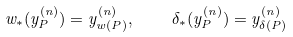<formula> <loc_0><loc_0><loc_500><loc_500>w _ { * } ( y _ { P } ^ { ( n ) } ) = y _ { w ( P ) } ^ { ( n ) } , \quad \delta _ { * } ( y _ { P } ^ { ( n ) } ) = y _ { \delta ( P ) } ^ { ( n ) }</formula> 